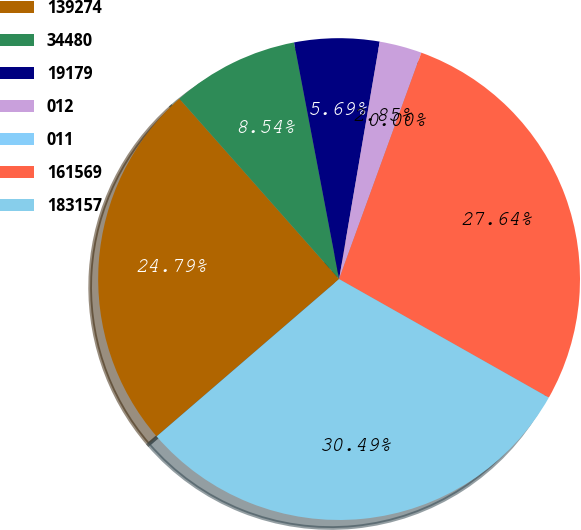<chart> <loc_0><loc_0><loc_500><loc_500><pie_chart><fcel>139274<fcel>34480<fcel>19179<fcel>012<fcel>011<fcel>161569<fcel>183157<nl><fcel>24.79%<fcel>8.54%<fcel>5.69%<fcel>2.85%<fcel>0.0%<fcel>27.64%<fcel>30.49%<nl></chart> 